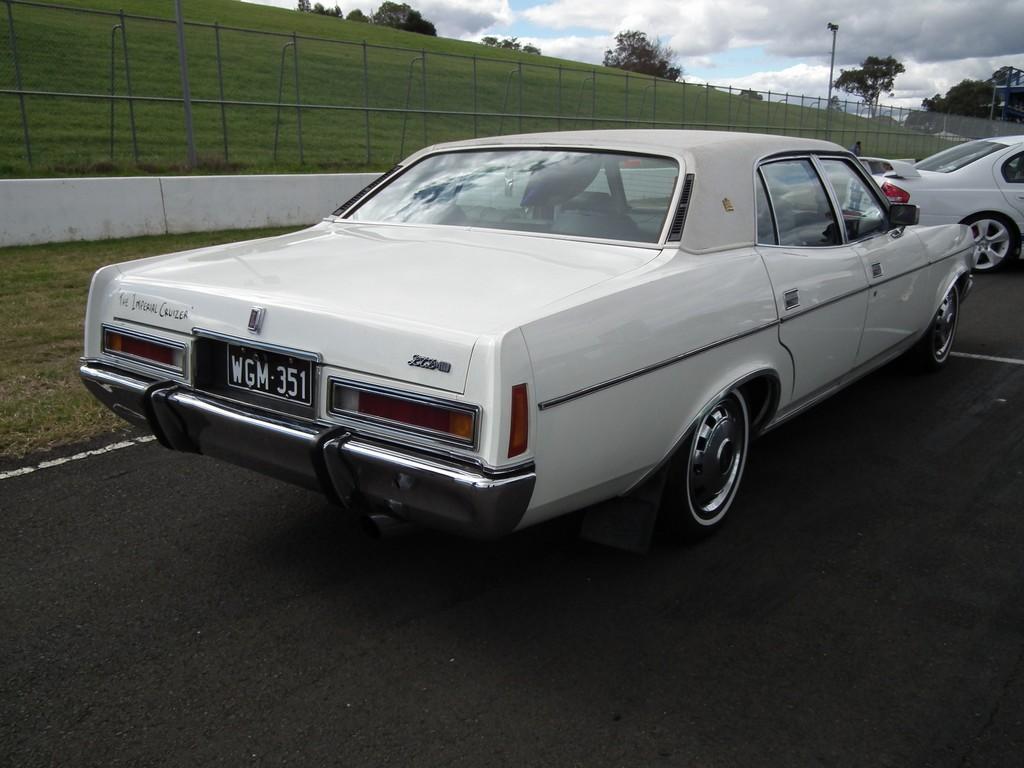Describe this image in one or two sentences. In this image I can see the vehicles on the road. To the side of the road I can see the railing, grass and the poles. In the background I can see many trees, clouds and the sky. 